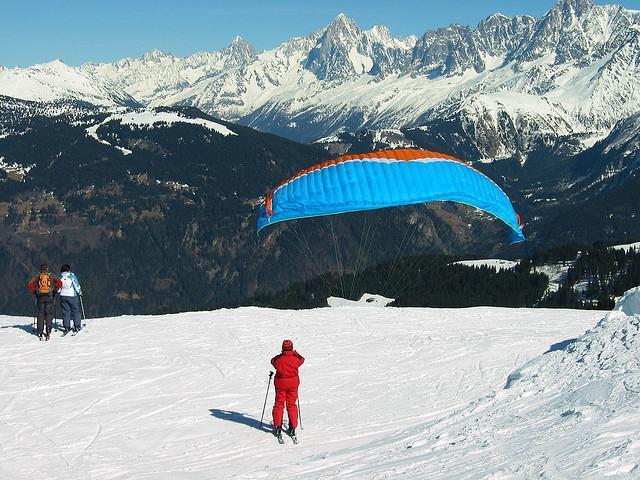How many people are seen?
Give a very brief answer. 3. 